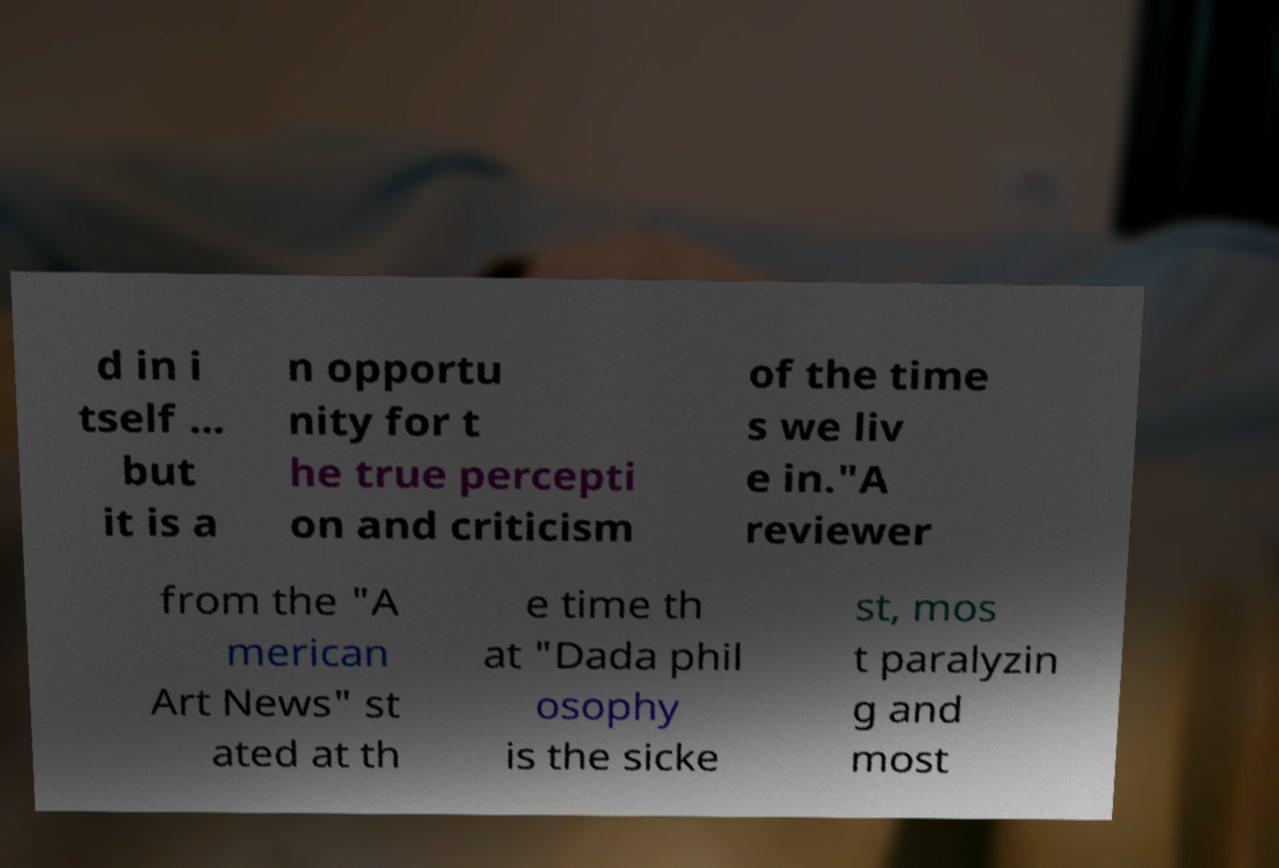Can you accurately transcribe the text from the provided image for me? d in i tself ... but it is a n opportu nity for t he true percepti on and criticism of the time s we liv e in."A reviewer from the "A merican Art News" st ated at th e time th at "Dada phil osophy is the sicke st, mos t paralyzin g and most 